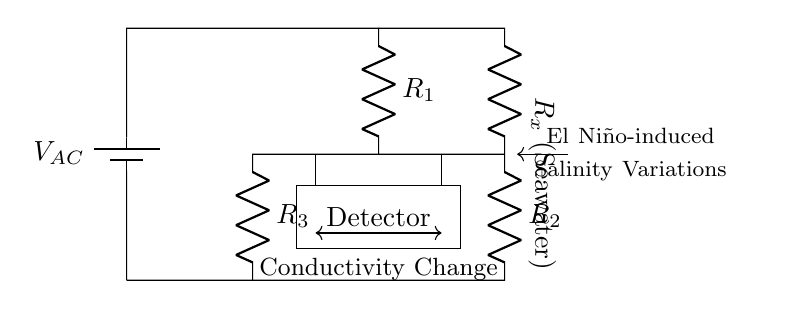What is the voltage source in this circuit? The voltage source is denoted as V AC, which indicates it provides an alternating current voltage to the circuit.
Answer: V AC What are the resistances present in the circuit? The circuit contains R one, R two, R three, and R x (the seawater resistance). These components are clearly labeled in the diagram.
Answer: R one, R two, R three, R x What is the purpose of the detector in the circuit? The detector is used to measure the output and determine changes in conductivity due to variations in seawater salinity during El Niño events, indicated by its labeling in the circuit.
Answer: Measure conductivity changes How does the seawater resistance R x affect the circuit? R x directly influences the balance of the AC bridge circuit. A change in seawater conductivity alters R x, which in turn affects the voltage output to the detector.
Answer: Alters voltage output Which component indicates seawater resistance? The component labeled as R x, positioned vertically in the circuit, specifically represents the resistance changes corresponding to seawater conductivity.
Answer: R x What happens in the circuit when seawater conductivity increases? An increase in seawater conductivity reduces R x, leading to changes in the detector output, indicating a shift towards balancing the bridge.
Answer: Shift in detector output How can this circuit help monitor El Niño events? The changes in seawater salinity due to El Niño influence conductivity, which this AC bridge circuit can detect through variations in resistance, enabling monitoring of environmental changes.
Answer: Detect environmental changes 